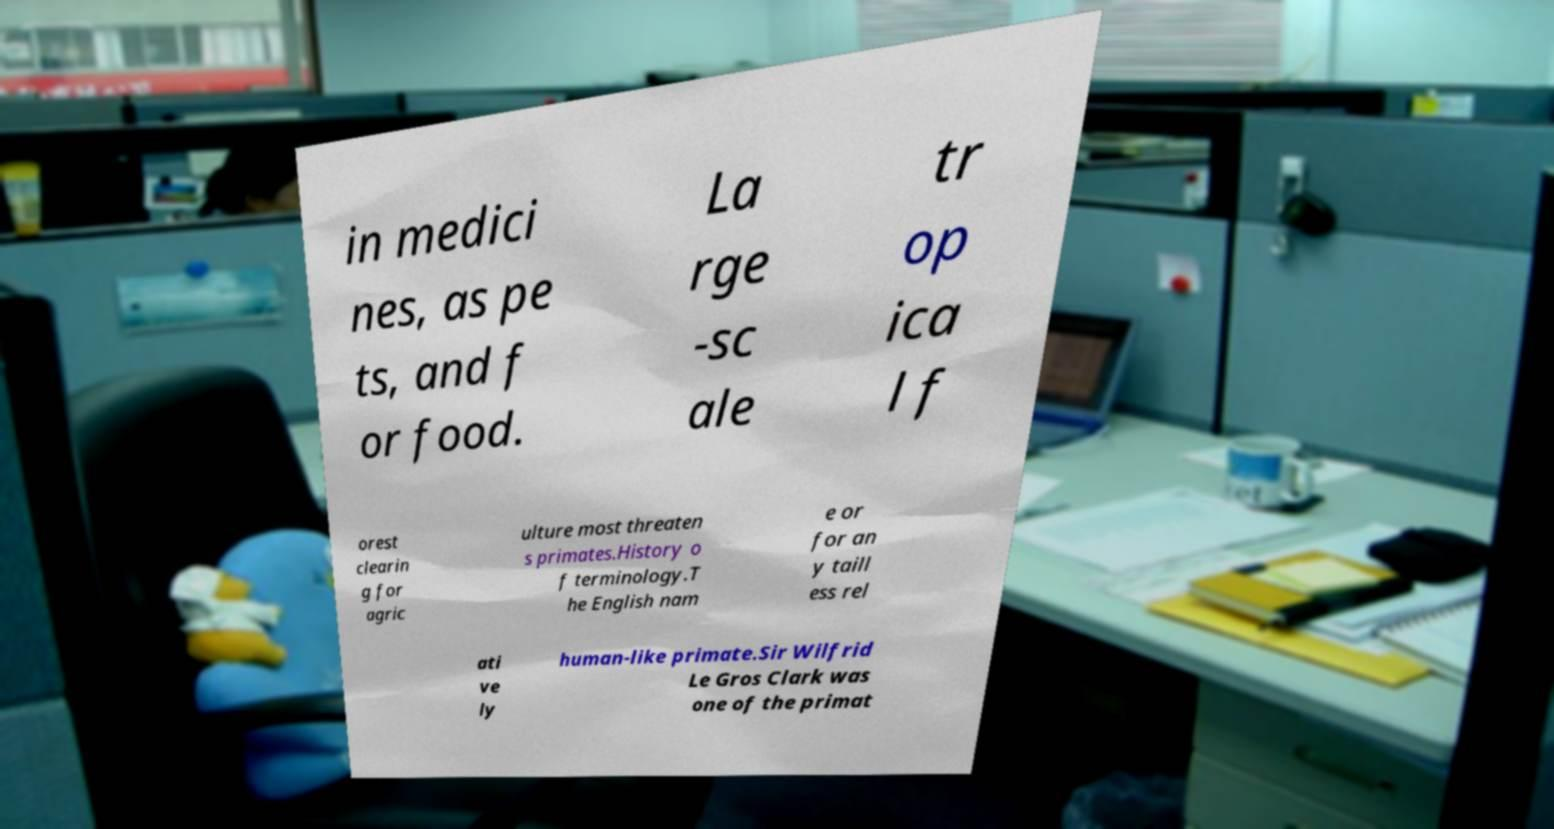Could you extract and type out the text from this image? in medici nes, as pe ts, and f or food. La rge -sc ale tr op ica l f orest clearin g for agric ulture most threaten s primates.History o f terminology.T he English nam e or for an y taill ess rel ati ve ly human-like primate.Sir Wilfrid Le Gros Clark was one of the primat 